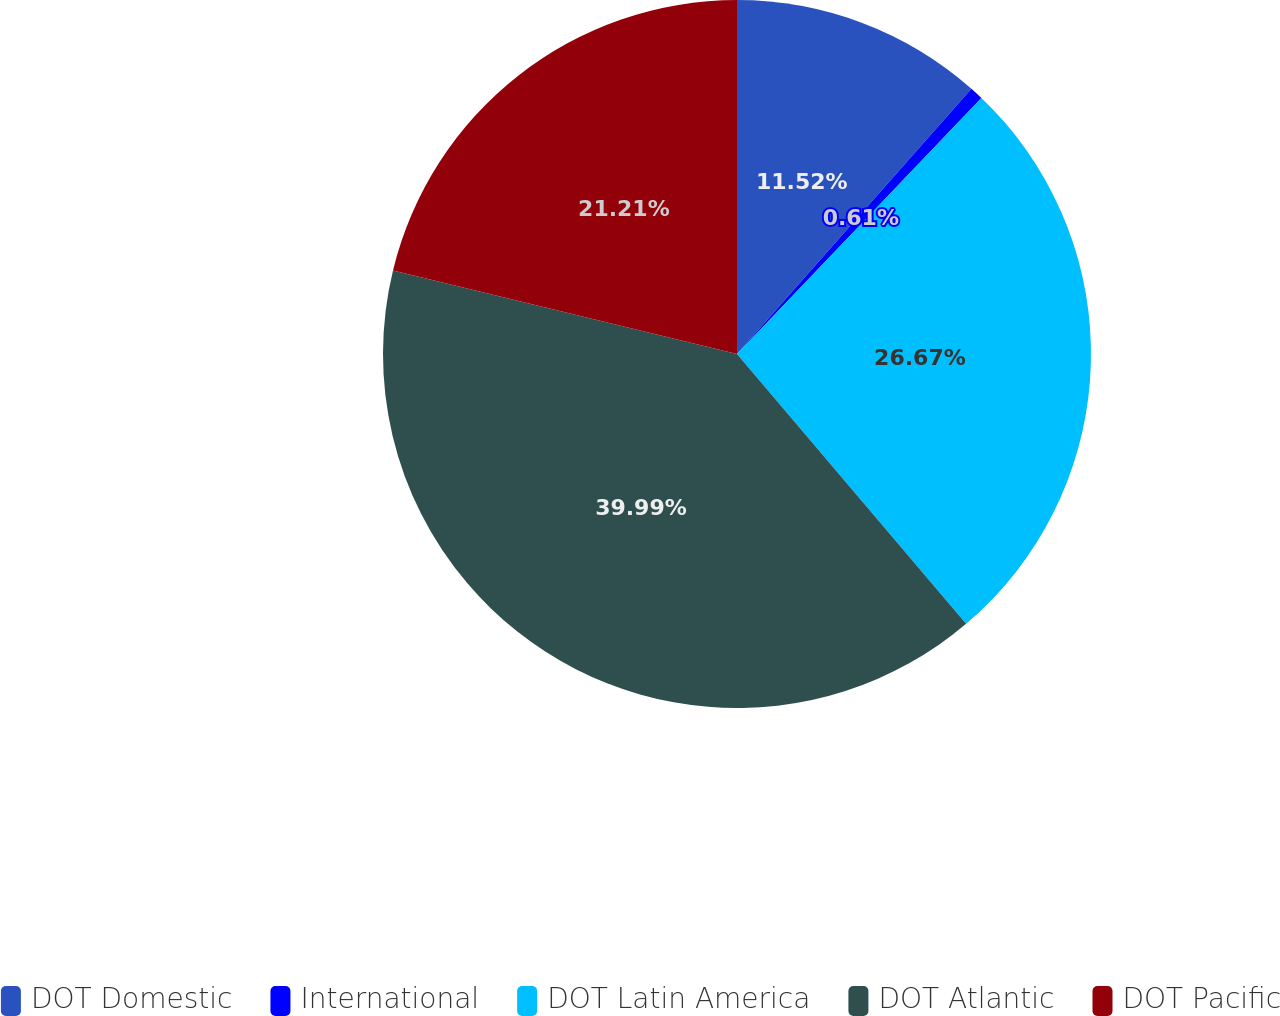<chart> <loc_0><loc_0><loc_500><loc_500><pie_chart><fcel>DOT Domestic<fcel>International<fcel>DOT Latin America<fcel>DOT Atlantic<fcel>DOT Pacific<nl><fcel>11.52%<fcel>0.61%<fcel>26.67%<fcel>40.0%<fcel>21.21%<nl></chart> 